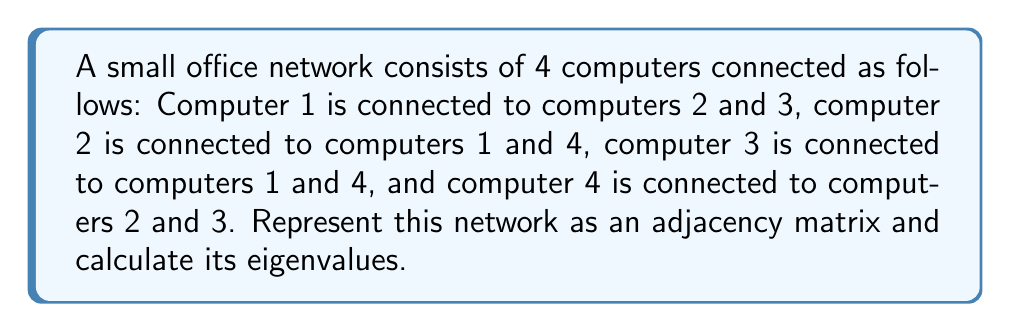Can you answer this question? Step 1: Create the adjacency matrix
The adjacency matrix A for this network is:
$$A = \begin{bmatrix}
0 & 1 & 1 & 0 \\
1 & 0 & 0 & 1 \\
1 & 0 & 0 & 1 \\
0 & 1 & 1 & 0
\end{bmatrix}$$

Step 2: Calculate the characteristic polynomial
To find the eigenvalues, we need to solve the characteristic equation:
$\det(A - \lambda I) = 0$

Expanding this:
$$\begin{vmatrix}
-\lambda & 1 & 1 & 0 \\
1 & -\lambda & 0 & 1 \\
1 & 0 & -\lambda & 1 \\
0 & 1 & 1 & -\lambda
\end{vmatrix} = 0$$

Step 3: Solve the characteristic equation
Expanding the determinant:
$\lambda^4 - 4\lambda^2 + 1 = 0$

This is a quadratic equation in $\lambda^2$. Let $u = \lambda^2$:
$u^2 - 4u + 1 = 0$

Using the quadratic formula:
$u = \frac{4 \pm \sqrt{16 - 4}}{2} = \frac{4 \pm \sqrt{12}}{2} = \frac{4 \pm 2\sqrt{3}}{2} = 2 \pm \sqrt{3}$

Step 4: Calculate the eigenvalues
Since $u = \lambda^2$, we have:
$\lambda^2 = 2 + \sqrt{3}$ or $\lambda^2 = 2 - \sqrt{3}$

Taking the square root of both sides:
$\lambda = \pm\sqrt{2 + \sqrt{3}}$ or $\lambda = \pm\sqrt{2 - \sqrt{3}}$
Answer: $\lambda = \pm\sqrt{2 + \sqrt{3}}, \pm\sqrt{2 - \sqrt{3}}$ 